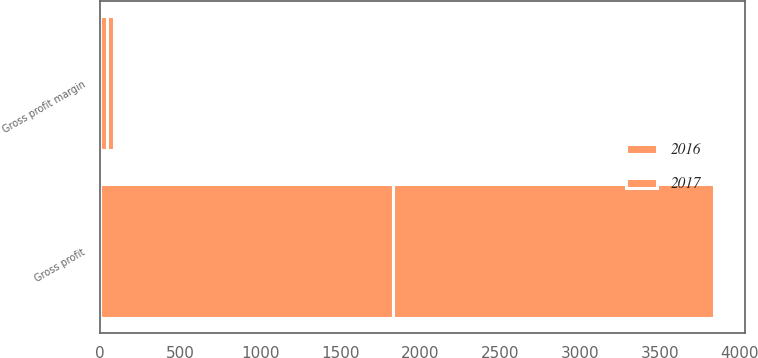Convert chart to OTSL. <chart><loc_0><loc_0><loc_500><loc_500><stacked_bar_chart><ecel><fcel>Gross profit<fcel>Gross profit margin<nl><fcel>2017<fcel>2010.2<fcel>41.6<nl><fcel>2016<fcel>1831.7<fcel>41.5<nl></chart> 